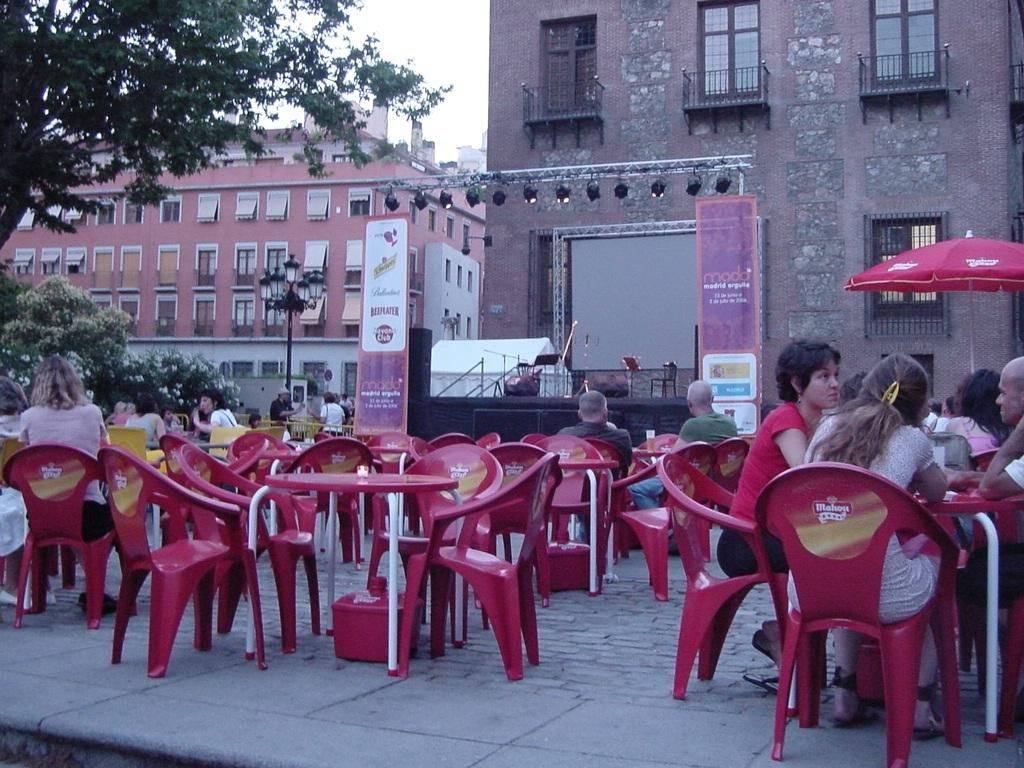What are the people in the image doing? The people in the image are sitting on chairs. What furniture is present in the image besides chairs? There are tables in the image. What type of structure is present in the image? There is a stage in the image. What can be seen in the background of the image? Trees, buildings, and the sky are visible in the image. What additional features are present in the image? Banners and lights with poles are present in the image. What type of map can be seen on the stage in the image? There is no map present on the stage or anywhere else in the image. What condition is the stick in, and where is it located in the image? There is no stick present in the image. 